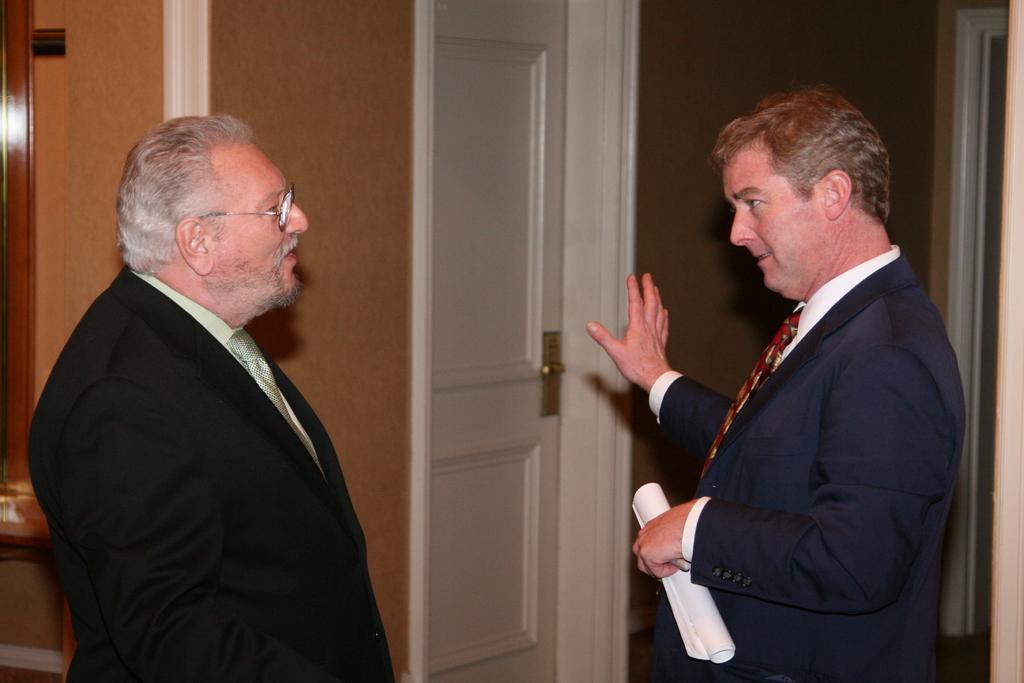How would you summarize this image in a sentence or two? In the center of the image we can see two persons are standing. And the right side person is holding a paper. In the background there is a wooden wall, door and a few other objects. 